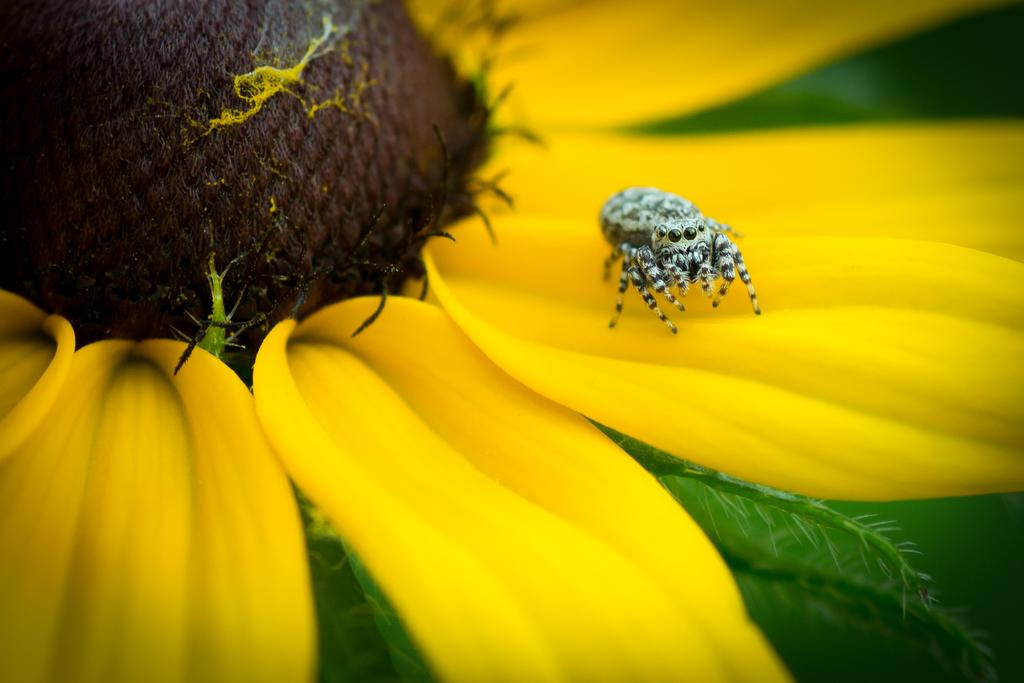What type of creature can be seen in the image? There is an insect in the image. Where is the insect located in the image? The insect is on the petal of a flower. What type of rule is being enforced by the insect in the image? There is no rule being enforced by the insect in the image, as it is simply an insect on a flower petal. How many bikes are visible in the image? There are no bikes present in the image; it features an insect on a flower petal. 